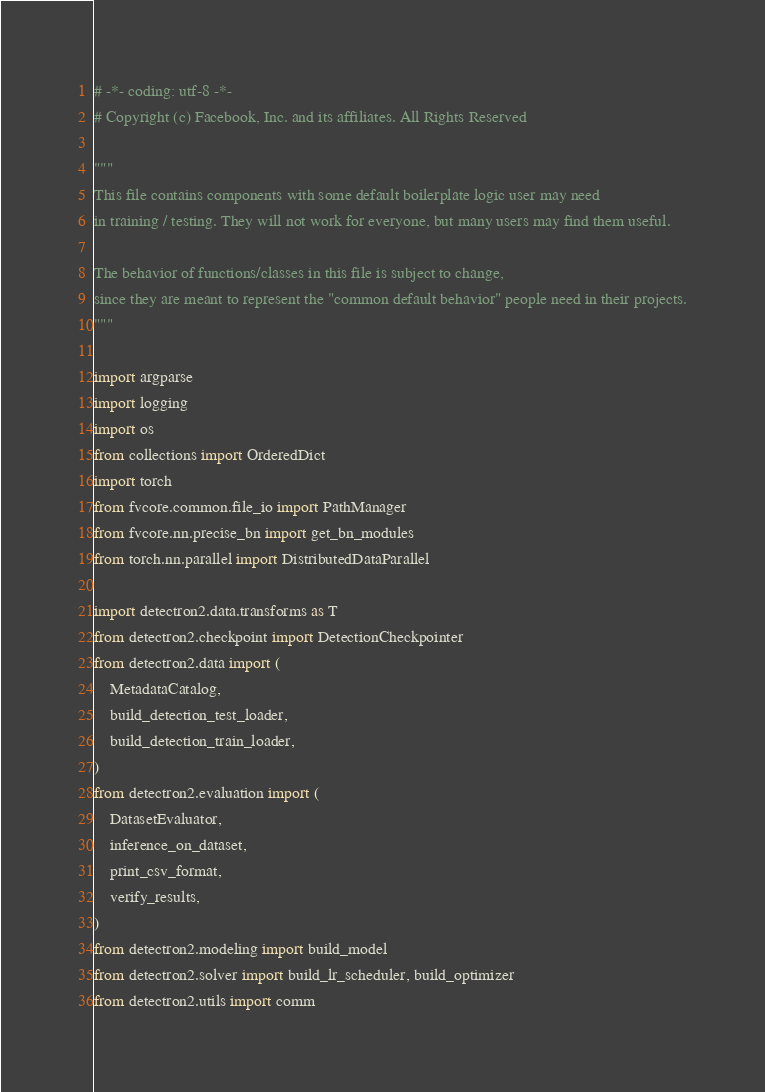<code> <loc_0><loc_0><loc_500><loc_500><_Python_># -*- coding: utf-8 -*-
# Copyright (c) Facebook, Inc. and its affiliates. All Rights Reserved

"""
This file contains components with some default boilerplate logic user may need
in training / testing. They will not work for everyone, but many users may find them useful.

The behavior of functions/classes in this file is subject to change,
since they are meant to represent the "common default behavior" people need in their projects.
"""

import argparse
import logging
import os
from collections import OrderedDict
import torch
from fvcore.common.file_io import PathManager
from fvcore.nn.precise_bn import get_bn_modules
from torch.nn.parallel import DistributedDataParallel

import detectron2.data.transforms as T
from detectron2.checkpoint import DetectionCheckpointer
from detectron2.data import (
    MetadataCatalog,
    build_detection_test_loader,
    build_detection_train_loader,
)
from detectron2.evaluation import (
    DatasetEvaluator,
    inference_on_dataset,
    print_csv_format,
    verify_results,
)
from detectron2.modeling import build_model
from detectron2.solver import build_lr_scheduler, build_optimizer
from detectron2.utils import comm</code> 